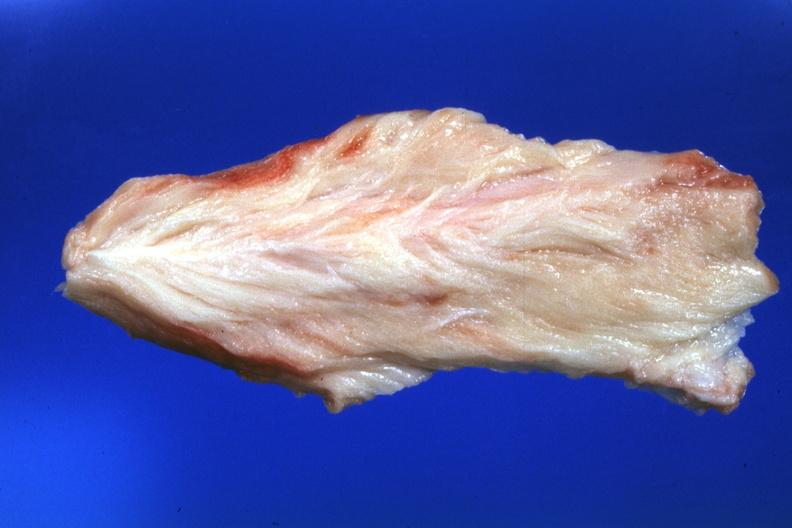s soft tissue present?
Answer the question using a single word or phrase. Yes 